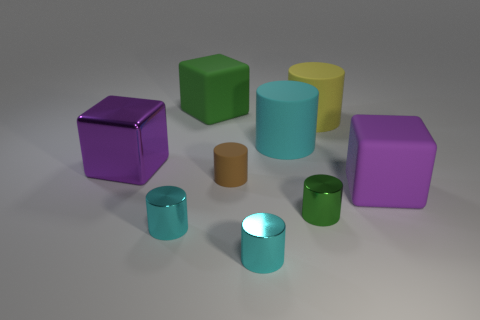What is the material of the large cyan object that is the same shape as the large yellow thing?
Your response must be concise. Rubber. What number of yellow objects are either tiny matte cylinders or cubes?
Your response must be concise. 0. Is there any other thing that is the same color as the small rubber cylinder?
Provide a succinct answer. No. There is a cube that is to the right of the cyan shiny cylinder on the right side of the big green object; what color is it?
Offer a very short reply. Purple. Are there fewer big green matte things to the right of the large yellow matte object than large green blocks on the right side of the big cyan cylinder?
Ensure brevity in your answer.  No. What is the material of the thing that is the same color as the metal cube?
Your answer should be compact. Rubber. How many objects are either large things in front of the large purple metallic cube or large purple matte cubes?
Keep it short and to the point. 1. Is the size of the purple object that is left of the yellow matte thing the same as the small green cylinder?
Keep it short and to the point. No. Is the number of large blocks to the right of the brown rubber thing less than the number of metallic objects?
Your answer should be very brief. Yes. What is the material of the green thing that is the same size as the brown cylinder?
Your response must be concise. Metal. 